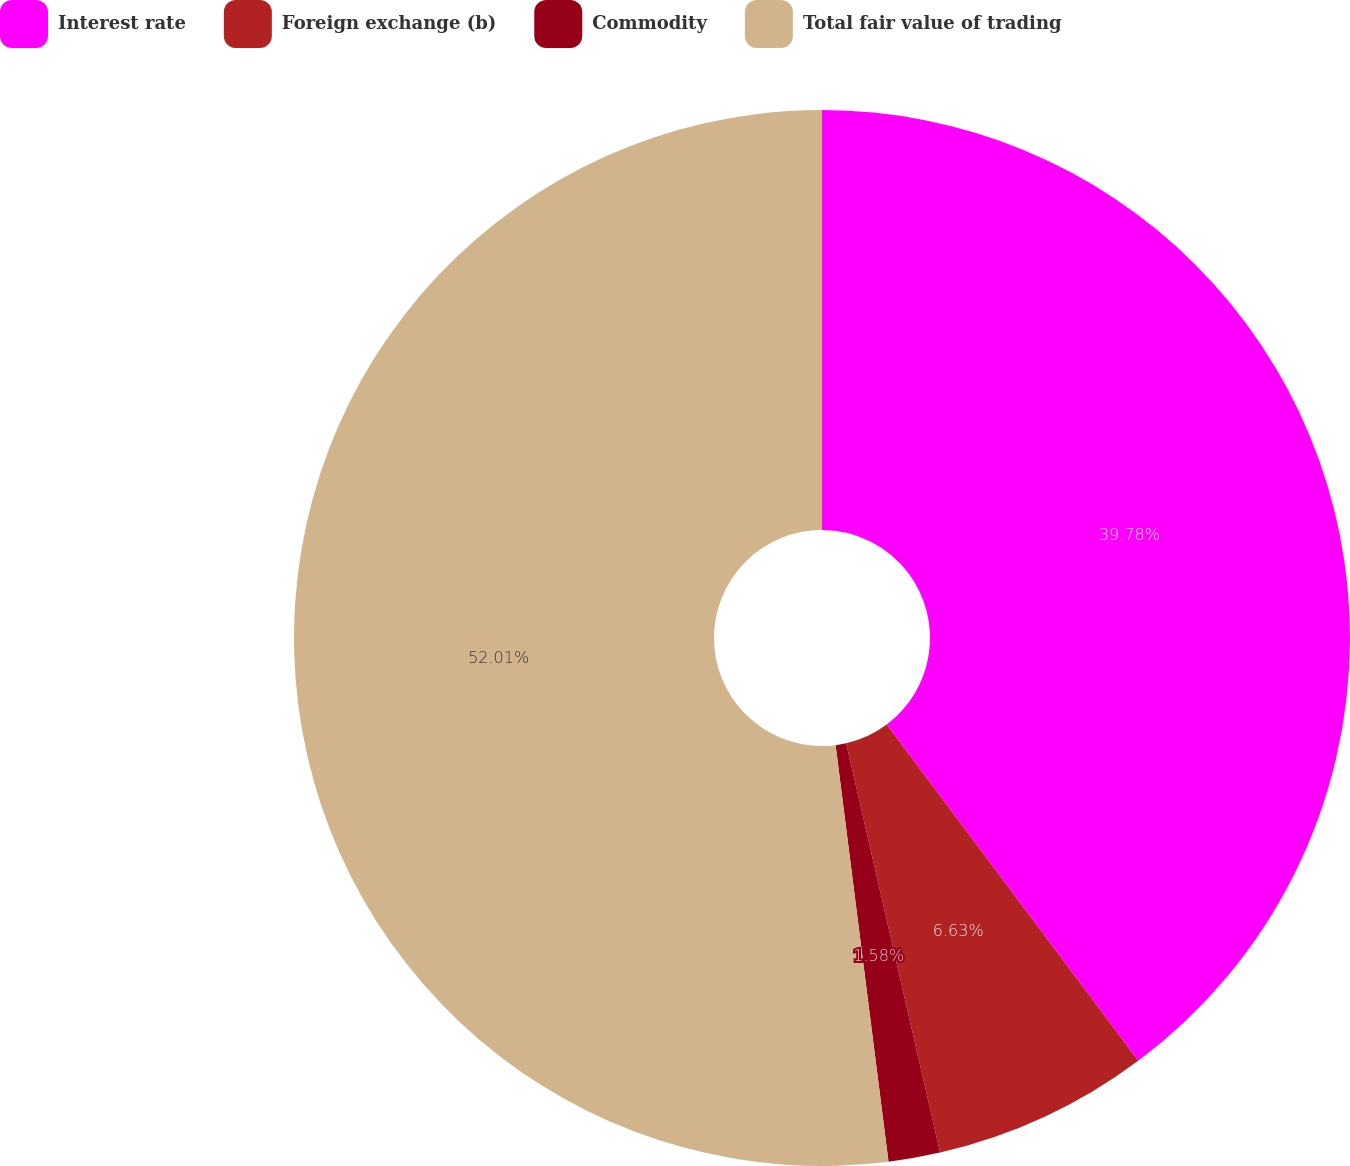Convert chart. <chart><loc_0><loc_0><loc_500><loc_500><pie_chart><fcel>Interest rate<fcel>Foreign exchange (b)<fcel>Commodity<fcel>Total fair value of trading<nl><fcel>39.78%<fcel>6.63%<fcel>1.58%<fcel>52.01%<nl></chart> 